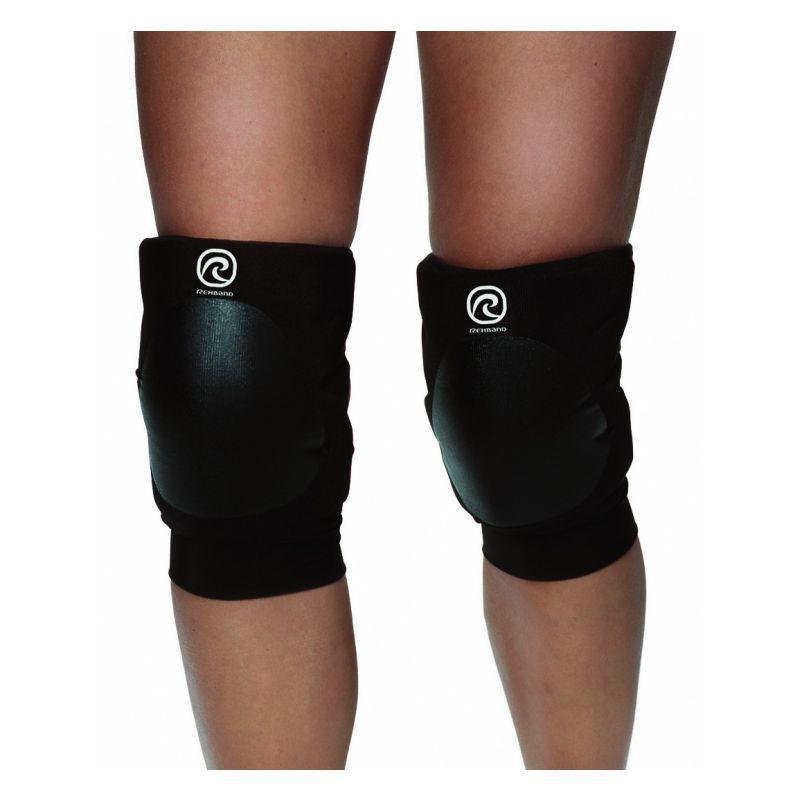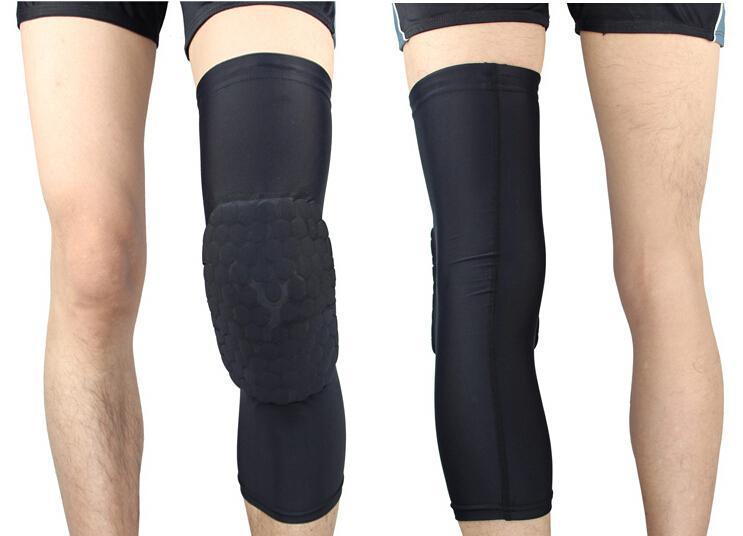The first image is the image on the left, the second image is the image on the right. For the images shown, is this caption "There are two sets of matching knee pads being worn by two people." true? Answer yes or no. No. 